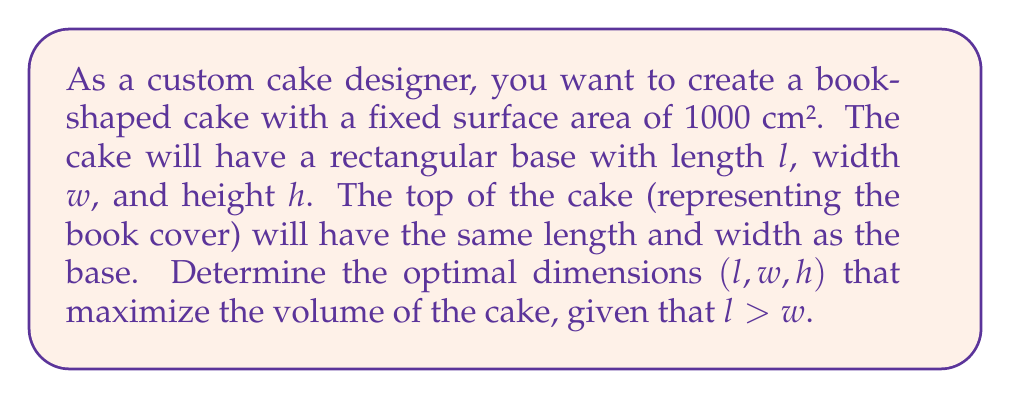Teach me how to tackle this problem. Let's approach this problem step-by-step using calculus:

1) First, we need to express the volume and surface area in terms of $l$, $w$, and $h$:

   Volume: $V = lwh$
   Surface Area: $SA = 2lw + 2lh + 2wh = 1000$

2) From the surface area equation, we can express $h$ in terms of $l$ and $w$:

   $2lw + 2lh + 2wh = 1000$
   $2h(l + w) = 1000 - 2lw$
   $h = \frac{500 - lw}{l + w}$

3) Now, we can express the volume as a function of $l$ and $w$:

   $V(l,w) = lw \cdot \frac{500 - lw}{l + w} = \frac{500lw - l^2w^2}{l + w}$

4) To find the maximum volume, we need to find the partial derivatives of $V$ with respect to $l$ and $w$ and set them to zero:

   $$\frac{\partial V}{\partial l} = \frac{500w(l+w) - 2lw^2(l+w) - (500lw - l^2w^2)}{(l+w)^2} = 0$$
   $$\frac{\partial V}{\partial w} = \frac{500l(l+w) - 2lw^2(l+w) - (500lw - l^2w^2)}{(l+w)^2} = 0$$

5) Simplifying these equations:

   $500w - 2lw^2 - 500w + l^2w = 0$
   $500l - 2lw^2 - 500w + l^2w = 0$

6) Subtracting the second equation from the first:

   $500w - 500l + l^2w - l^2w = 0$
   $500(w - l) = 0$
   $w = l$

7) However, we're given that $l > w$. This means that the maximum volume occurs when $l$ is slightly larger than $w$. In practice, we can approximate this by setting $l = w + \epsilon$, where $\epsilon$ is a small positive number.

8) Substituting this back into the surface area equation:

   $2(w+\epsilon)w + 2(w+\epsilon)h + 2wh = 1000$
   $2w^2 + 2\epsilon w + 2wh + 2\epsilon h + 2wh = 1000$
   $2w^2 + 2\epsilon w + 4wh + 2\epsilon h = 1000$

9) As $\epsilon$ is very small, we can approximate:

   $2w^2 + 4wh \approx 1000$
   $w^2 + 2wh = 500$
   $h = \frac{500 - w^2}{2w}$

10) The volume is then:

    $V = w(w+\epsilon)\frac{500 - w^2}{2w} \approx \frac{w(500 - w^2)}{2}$

11) To find the maximum, differentiate with respect to $w$ and set to zero:

    $\frac{dV}{dw} = \frac{500 - 3w^2}{2} = 0$
    $500 - 3w^2 = 0$
    $w^2 = \frac{500}{3}$
    $w = \sqrt{\frac{500}{3}} \approx 12.91$

12) Rounding to practical dimensions and ensuring $l > w$, we can set:
    $w = 12.9$ cm, $l = 13.0$ cm
    $h = \frac{500 - w^2}{2w} \approx 12.9$ cm
Answer: The optimal dimensions for the book-shaped cake to maximize volume are approximately:
Length: $l \approx 13.0$ cm
Width: $w \approx 12.9$ cm
Height: $h \approx 12.9$ cm 